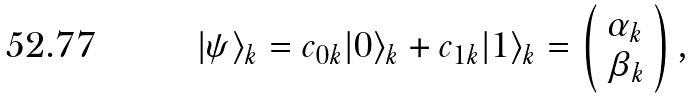<formula> <loc_0><loc_0><loc_500><loc_500>| \psi \rangle _ { k } = c _ { 0 k } | 0 \rangle _ { k } + c _ { 1 k } | 1 \rangle _ { k } = \left ( \begin{array} { c } \alpha _ { k } \\ \beta _ { k } \end{array} \right ) ,</formula> 